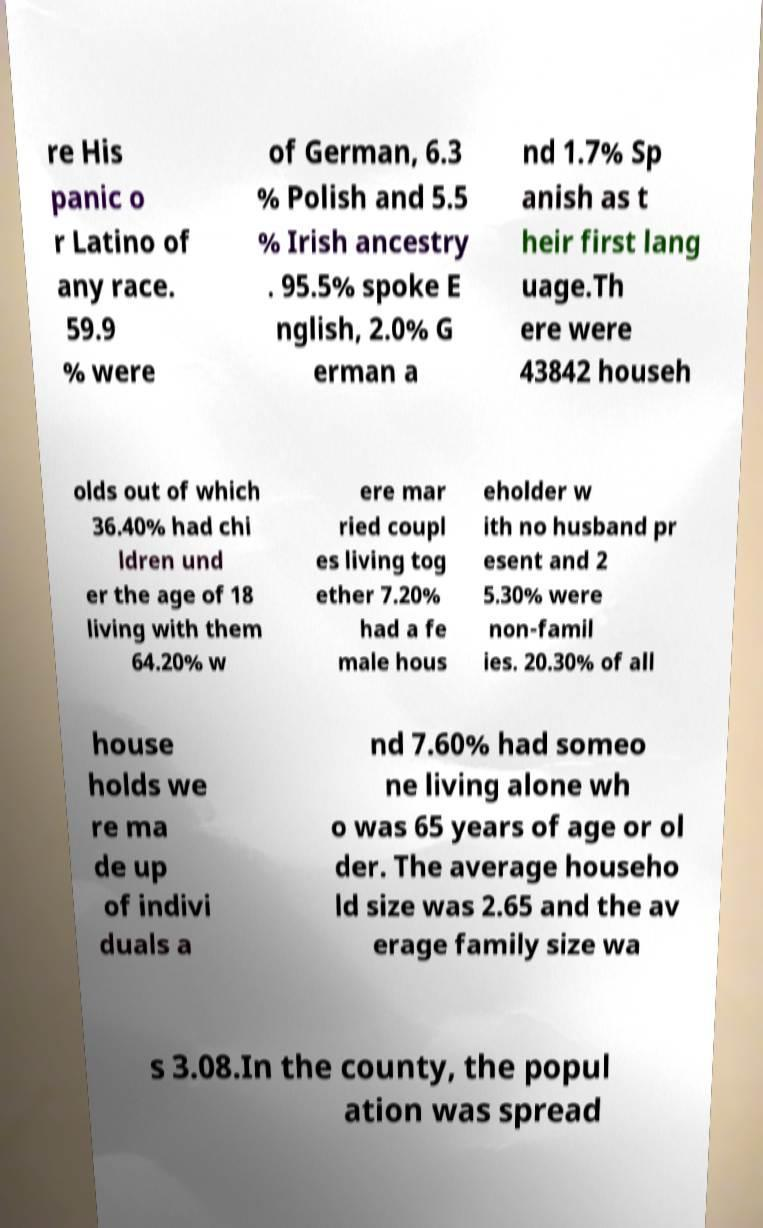Please read and relay the text visible in this image. What does it say? re His panic o r Latino of any race. 59.9 % were of German, 6.3 % Polish and 5.5 % Irish ancestry . 95.5% spoke E nglish, 2.0% G erman a nd 1.7% Sp anish as t heir first lang uage.Th ere were 43842 househ olds out of which 36.40% had chi ldren und er the age of 18 living with them 64.20% w ere mar ried coupl es living tog ether 7.20% had a fe male hous eholder w ith no husband pr esent and 2 5.30% were non-famil ies. 20.30% of all house holds we re ma de up of indivi duals a nd 7.60% had someo ne living alone wh o was 65 years of age or ol der. The average househo ld size was 2.65 and the av erage family size wa s 3.08.In the county, the popul ation was spread 